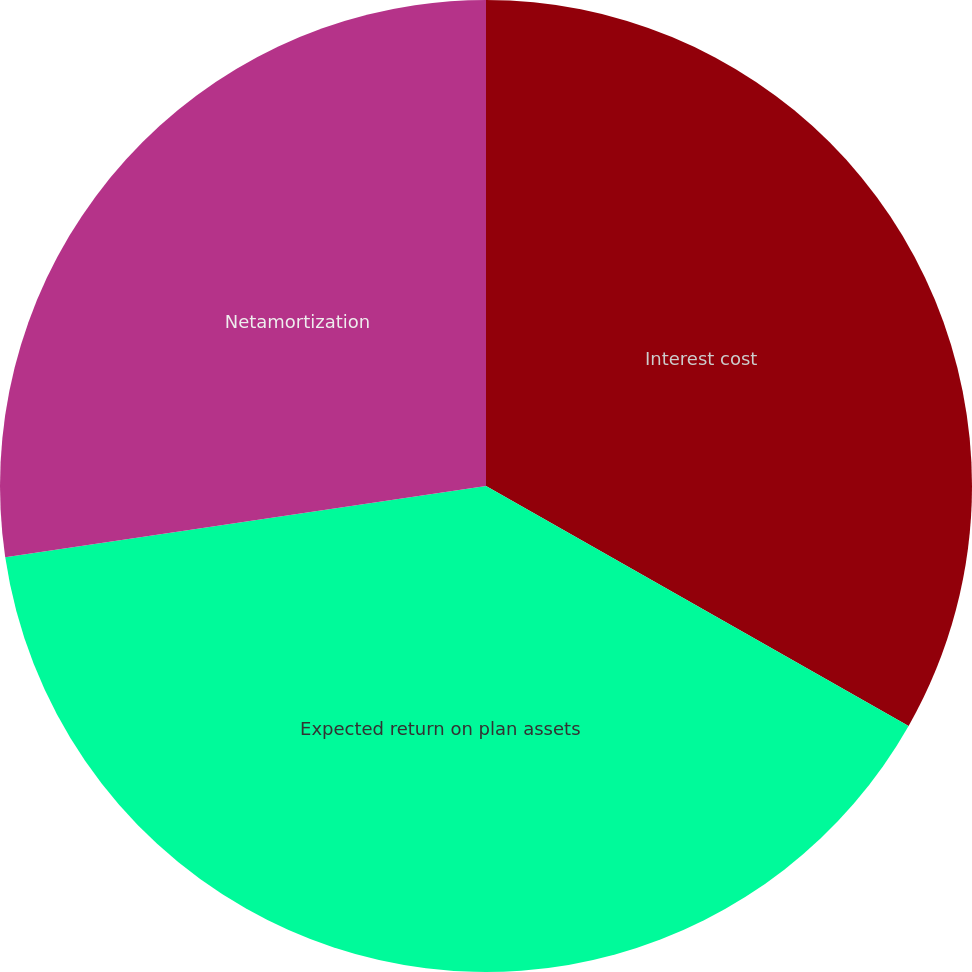<chart> <loc_0><loc_0><loc_500><loc_500><pie_chart><fcel>Interest cost<fcel>Expected return on plan assets<fcel>Netamortization<nl><fcel>33.22%<fcel>39.44%<fcel>27.34%<nl></chart> 